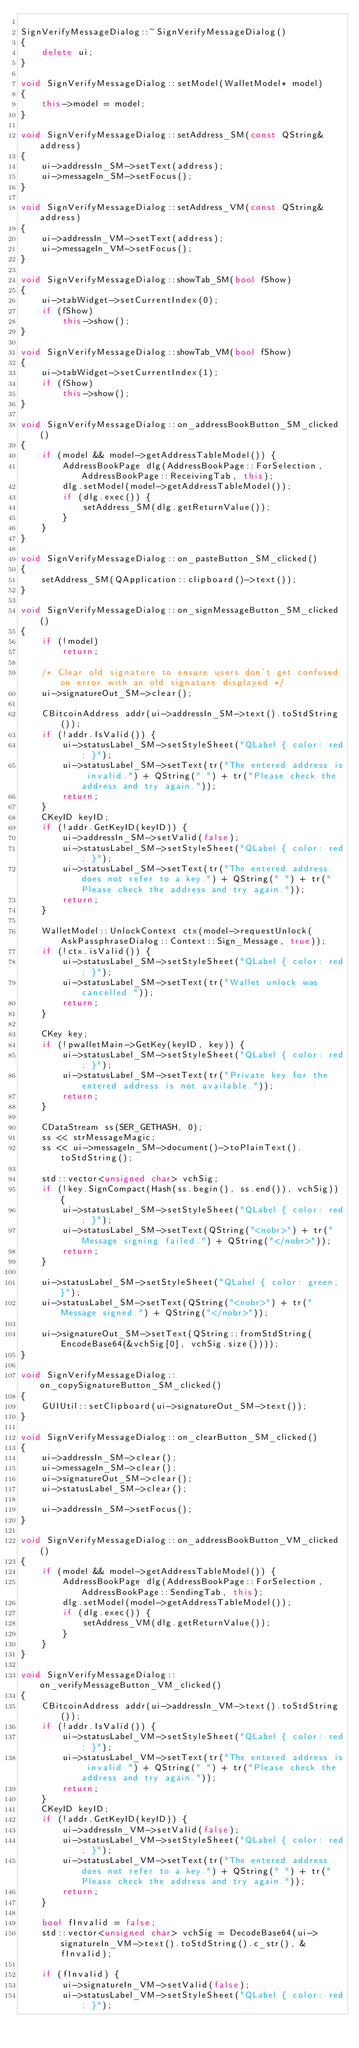<code> <loc_0><loc_0><loc_500><loc_500><_C++_>
SignVerifyMessageDialog::~SignVerifyMessageDialog()
{
    delete ui;
}

void SignVerifyMessageDialog::setModel(WalletModel* model)
{
    this->model = model;
}

void SignVerifyMessageDialog::setAddress_SM(const QString& address)
{
    ui->addressIn_SM->setText(address);
    ui->messageIn_SM->setFocus();
}

void SignVerifyMessageDialog::setAddress_VM(const QString& address)
{
    ui->addressIn_VM->setText(address);
    ui->messageIn_VM->setFocus();
}

void SignVerifyMessageDialog::showTab_SM(bool fShow)
{
    ui->tabWidget->setCurrentIndex(0);
    if (fShow)
        this->show();
}

void SignVerifyMessageDialog::showTab_VM(bool fShow)
{
    ui->tabWidget->setCurrentIndex(1);
    if (fShow)
        this->show();
}

void SignVerifyMessageDialog::on_addressBookButton_SM_clicked()
{
    if (model && model->getAddressTableModel()) {
        AddressBookPage dlg(AddressBookPage::ForSelection, AddressBookPage::ReceivingTab, this);
        dlg.setModel(model->getAddressTableModel());
        if (dlg.exec()) {
            setAddress_SM(dlg.getReturnValue());
        }
    }
}

void SignVerifyMessageDialog::on_pasteButton_SM_clicked()
{
    setAddress_SM(QApplication::clipboard()->text());
}

void SignVerifyMessageDialog::on_signMessageButton_SM_clicked()
{
    if (!model)
        return;

    /* Clear old signature to ensure users don't get confused on error with an old signature displayed */
    ui->signatureOut_SM->clear();

    CBitcoinAddress addr(ui->addressIn_SM->text().toStdString());
    if (!addr.IsValid()) {
        ui->statusLabel_SM->setStyleSheet("QLabel { color: red; }");
        ui->statusLabel_SM->setText(tr("The entered address is invalid.") + QString(" ") + tr("Please check the address and try again."));
        return;
    }
    CKeyID keyID;
    if (!addr.GetKeyID(keyID)) {
        ui->addressIn_SM->setValid(false);
        ui->statusLabel_SM->setStyleSheet("QLabel { color: red; }");
        ui->statusLabel_SM->setText(tr("The entered address does not refer to a key.") + QString(" ") + tr("Please check the address and try again."));
        return;
    }

    WalletModel::UnlockContext ctx(model->requestUnlock(AskPassphraseDialog::Context::Sign_Message, true));
    if (!ctx.isValid()) {
        ui->statusLabel_SM->setStyleSheet("QLabel { color: red; }");
        ui->statusLabel_SM->setText(tr("Wallet unlock was cancelled."));
        return;
    }

    CKey key;
    if (!pwalletMain->GetKey(keyID, key)) {
        ui->statusLabel_SM->setStyleSheet("QLabel { color: red; }");
        ui->statusLabel_SM->setText(tr("Private key for the entered address is not available."));
        return;
    }

    CDataStream ss(SER_GETHASH, 0);
    ss << strMessageMagic;
    ss << ui->messageIn_SM->document()->toPlainText().toStdString();

    std::vector<unsigned char> vchSig;
    if (!key.SignCompact(Hash(ss.begin(), ss.end()), vchSig)) {
        ui->statusLabel_SM->setStyleSheet("QLabel { color: red; }");
        ui->statusLabel_SM->setText(QString("<nobr>") + tr("Message signing failed.") + QString("</nobr>"));
        return;
    }

    ui->statusLabel_SM->setStyleSheet("QLabel { color: green; }");
    ui->statusLabel_SM->setText(QString("<nobr>") + tr("Message signed.") + QString("</nobr>"));

    ui->signatureOut_SM->setText(QString::fromStdString(EncodeBase64(&vchSig[0], vchSig.size())));
}

void SignVerifyMessageDialog::on_copySignatureButton_SM_clicked()
{
    GUIUtil::setClipboard(ui->signatureOut_SM->text());
}

void SignVerifyMessageDialog::on_clearButton_SM_clicked()
{
    ui->addressIn_SM->clear();
    ui->messageIn_SM->clear();
    ui->signatureOut_SM->clear();
    ui->statusLabel_SM->clear();

    ui->addressIn_SM->setFocus();
}

void SignVerifyMessageDialog::on_addressBookButton_VM_clicked()
{
    if (model && model->getAddressTableModel()) {
        AddressBookPage dlg(AddressBookPage::ForSelection, AddressBookPage::SendingTab, this);
        dlg.setModel(model->getAddressTableModel());
        if (dlg.exec()) {
            setAddress_VM(dlg.getReturnValue());
        }
    }
}

void SignVerifyMessageDialog::on_verifyMessageButton_VM_clicked()
{
    CBitcoinAddress addr(ui->addressIn_VM->text().toStdString());
    if (!addr.IsValid()) {
        ui->statusLabel_VM->setStyleSheet("QLabel { color: red; }");
        ui->statusLabel_VM->setText(tr("The entered address is invalid.") + QString(" ") + tr("Please check the address and try again."));
        return;
    }
    CKeyID keyID;
    if (!addr.GetKeyID(keyID)) {
        ui->addressIn_VM->setValid(false);
        ui->statusLabel_VM->setStyleSheet("QLabel { color: red; }");
        ui->statusLabel_VM->setText(tr("The entered address does not refer to a key.") + QString(" ") + tr("Please check the address and try again."));
        return;
    }

    bool fInvalid = false;
    std::vector<unsigned char> vchSig = DecodeBase64(ui->signatureIn_VM->text().toStdString().c_str(), &fInvalid);

    if (fInvalid) {
        ui->signatureIn_VM->setValid(false);
        ui->statusLabel_VM->setStyleSheet("QLabel { color: red; }");</code> 